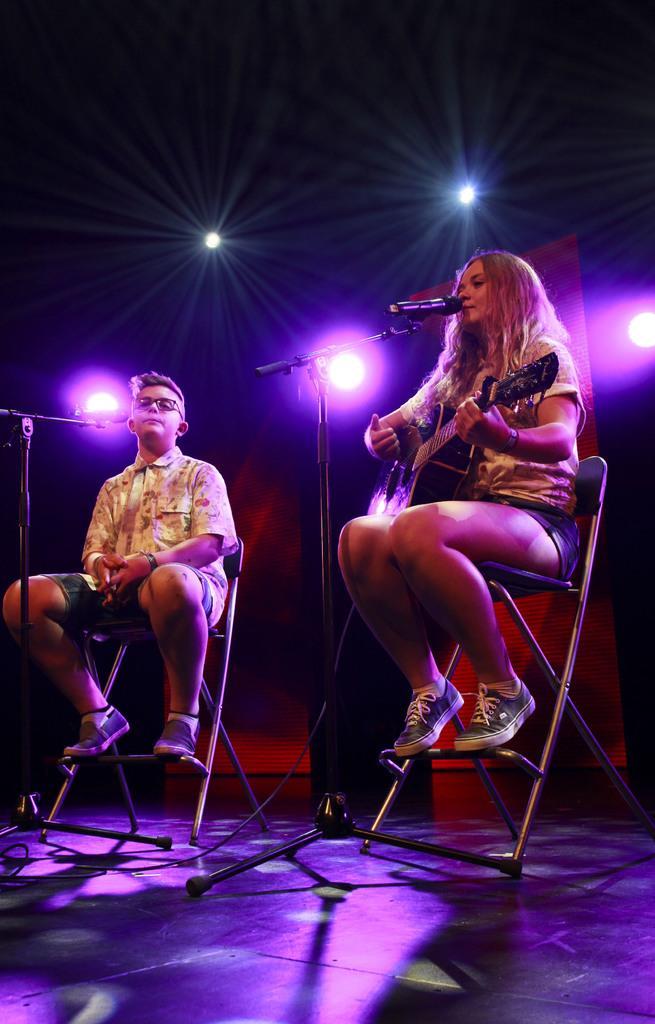Could you give a brief overview of what you see in this image? A lady holding guitar and sitting on a chair. In front of her there is a mic and mic stand. A boy on the left side is sitting on a chair. In front of him there is a mic and mic stand. In the background there are lights and a wall. 